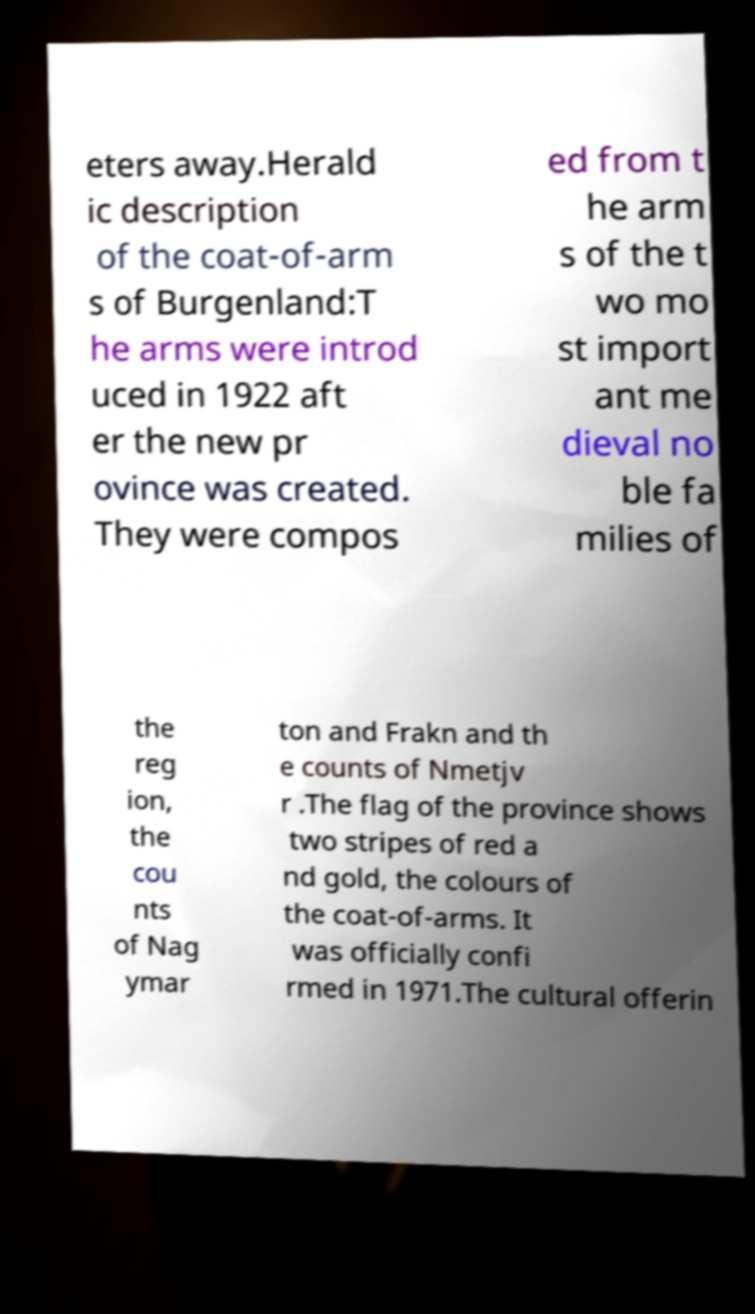Please read and relay the text visible in this image. What does it say? eters away.Herald ic description of the coat-of-arm s of Burgenland:T he arms were introd uced in 1922 aft er the new pr ovince was created. They were compos ed from t he arm s of the t wo mo st import ant me dieval no ble fa milies of the reg ion, the cou nts of Nag ymar ton and Frakn and th e counts of Nmetjv r .The flag of the province shows two stripes of red a nd gold, the colours of the coat-of-arms. It was officially confi rmed in 1971.The cultural offerin 